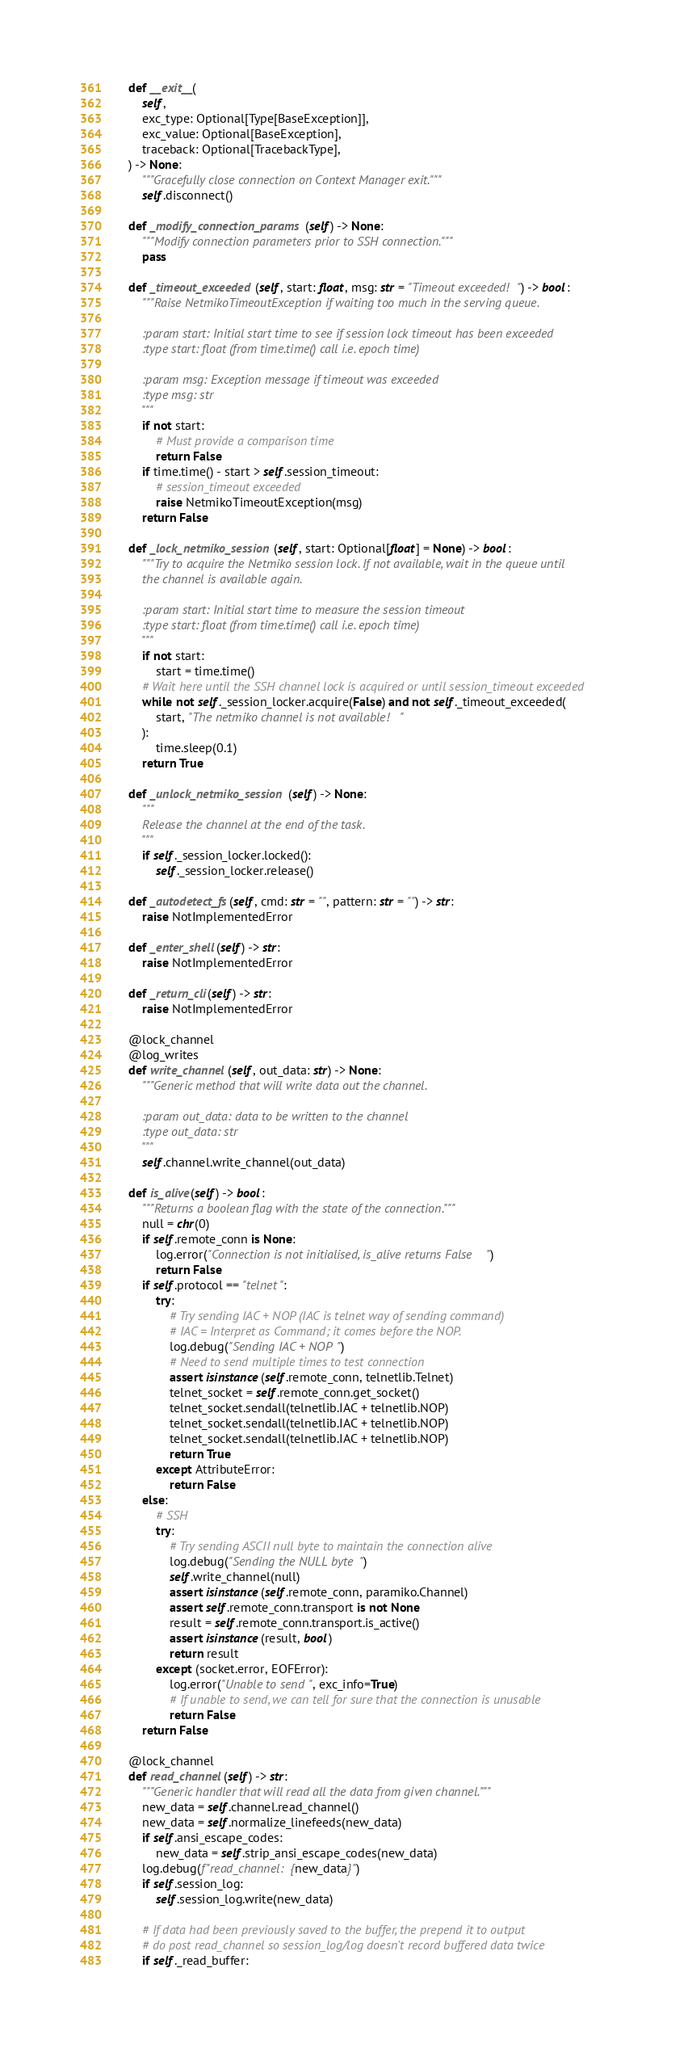Convert code to text. <code><loc_0><loc_0><loc_500><loc_500><_Python_>
    def __exit__(
        self,
        exc_type: Optional[Type[BaseException]],
        exc_value: Optional[BaseException],
        traceback: Optional[TracebackType],
    ) -> None:
        """Gracefully close connection on Context Manager exit."""
        self.disconnect()

    def _modify_connection_params(self) -> None:
        """Modify connection parameters prior to SSH connection."""
        pass

    def _timeout_exceeded(self, start: float, msg: str = "Timeout exceeded!") -> bool:
        """Raise NetmikoTimeoutException if waiting too much in the serving queue.

        :param start: Initial start time to see if session lock timeout has been exceeded
        :type start: float (from time.time() call i.e. epoch time)

        :param msg: Exception message if timeout was exceeded
        :type msg: str
        """
        if not start:
            # Must provide a comparison time
            return False
        if time.time() - start > self.session_timeout:
            # session_timeout exceeded
            raise NetmikoTimeoutException(msg)
        return False

    def _lock_netmiko_session(self, start: Optional[float] = None) -> bool:
        """Try to acquire the Netmiko session lock. If not available, wait in the queue until
        the channel is available again.

        :param start: Initial start time to measure the session timeout
        :type start: float (from time.time() call i.e. epoch time)
        """
        if not start:
            start = time.time()
        # Wait here until the SSH channel lock is acquired or until session_timeout exceeded
        while not self._session_locker.acquire(False) and not self._timeout_exceeded(
            start, "The netmiko channel is not available!"
        ):
            time.sleep(0.1)
        return True

    def _unlock_netmiko_session(self) -> None:
        """
        Release the channel at the end of the task.
        """
        if self._session_locker.locked():
            self._session_locker.release()

    def _autodetect_fs(self, cmd: str = "", pattern: str = "") -> str:
        raise NotImplementedError

    def _enter_shell(self) -> str:
        raise NotImplementedError

    def _return_cli(self) -> str:
        raise NotImplementedError

    @lock_channel
    @log_writes
    def write_channel(self, out_data: str) -> None:
        """Generic method that will write data out the channel.

        :param out_data: data to be written to the channel
        :type out_data: str
        """
        self.channel.write_channel(out_data)

    def is_alive(self) -> bool:
        """Returns a boolean flag with the state of the connection."""
        null = chr(0)
        if self.remote_conn is None:
            log.error("Connection is not initialised, is_alive returns False")
            return False
        if self.protocol == "telnet":
            try:
                # Try sending IAC + NOP (IAC is telnet way of sending command)
                # IAC = Interpret as Command; it comes before the NOP.
                log.debug("Sending IAC + NOP")
                # Need to send multiple times to test connection
                assert isinstance(self.remote_conn, telnetlib.Telnet)
                telnet_socket = self.remote_conn.get_socket()
                telnet_socket.sendall(telnetlib.IAC + telnetlib.NOP)
                telnet_socket.sendall(telnetlib.IAC + telnetlib.NOP)
                telnet_socket.sendall(telnetlib.IAC + telnetlib.NOP)
                return True
            except AttributeError:
                return False
        else:
            # SSH
            try:
                # Try sending ASCII null byte to maintain the connection alive
                log.debug("Sending the NULL byte")
                self.write_channel(null)
                assert isinstance(self.remote_conn, paramiko.Channel)
                assert self.remote_conn.transport is not None
                result = self.remote_conn.transport.is_active()
                assert isinstance(result, bool)
                return result
            except (socket.error, EOFError):
                log.error("Unable to send", exc_info=True)
                # If unable to send, we can tell for sure that the connection is unusable
                return False
        return False

    @lock_channel
    def read_channel(self) -> str:
        """Generic handler that will read all the data from given channel."""
        new_data = self.channel.read_channel()
        new_data = self.normalize_linefeeds(new_data)
        if self.ansi_escape_codes:
            new_data = self.strip_ansi_escape_codes(new_data)
        log.debug(f"read_channel: {new_data}")
        if self.session_log:
            self.session_log.write(new_data)

        # If data had been previously saved to the buffer, the prepend it to output
        # do post read_channel so session_log/log doesn't record buffered data twice
        if self._read_buffer:</code> 